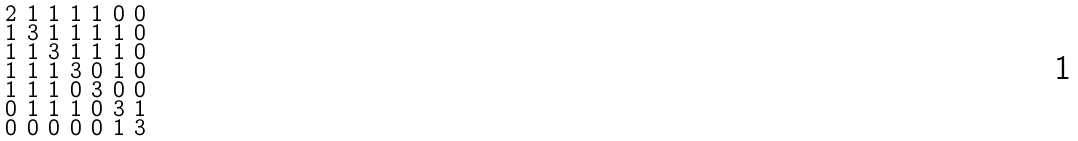Convert formula to latex. <formula><loc_0><loc_0><loc_500><loc_500>\begin{smallmatrix} 2 & 1 & 1 & 1 & 1 & 0 & 0 \\ 1 & 3 & 1 & 1 & 1 & 1 & 0 \\ 1 & 1 & 3 & 1 & 1 & 1 & 0 \\ 1 & 1 & 1 & 3 & 0 & 1 & 0 \\ 1 & 1 & 1 & 0 & 3 & 0 & 0 \\ 0 & 1 & 1 & 1 & 0 & 3 & 1 \\ 0 & 0 & 0 & 0 & 0 & 1 & 3 \end{smallmatrix}</formula> 